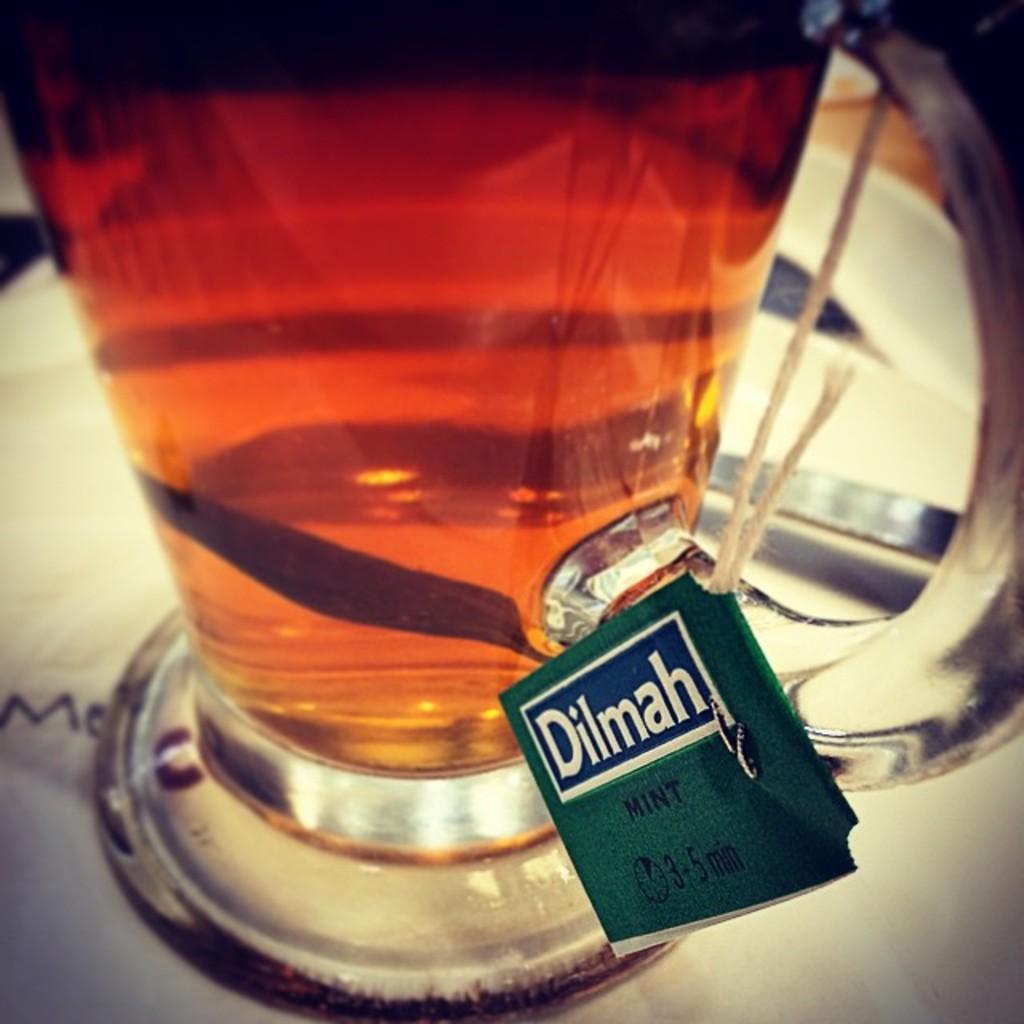Could you give a brief overview of what you see in this image? In the image there is a teacup with tea bag and spoon on a plate. 